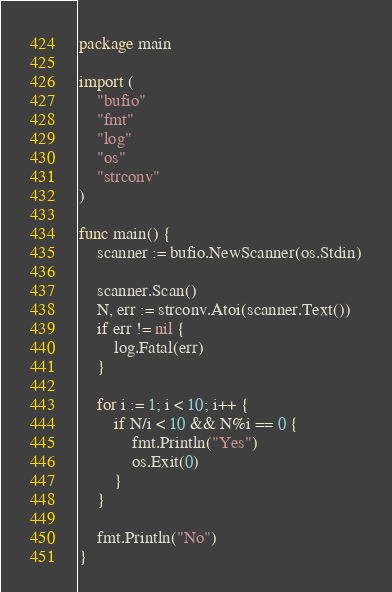Convert code to text. <code><loc_0><loc_0><loc_500><loc_500><_Go_>package main

import (
	"bufio"
	"fmt"
	"log"
	"os"
	"strconv"
)

func main() {
	scanner := bufio.NewScanner(os.Stdin)

	scanner.Scan()
	N, err := strconv.Atoi(scanner.Text())
	if err != nil {
		log.Fatal(err)
	}

	for i := 1; i < 10; i++ {
		if N/i < 10 && N%i == 0 {
			fmt.Println("Yes")
			os.Exit(0)
		}
	}

	fmt.Println("No")
}
</code> 